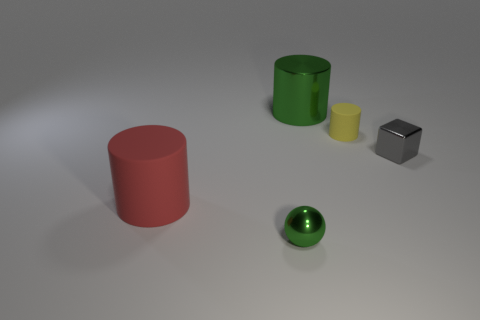There is a green metal thing in front of the big thing in front of the big green cylinder; what shape is it?
Give a very brief answer. Sphere. There is a shiny thing that is both on the left side of the small matte thing and behind the green metal sphere; what is its size?
Keep it short and to the point. Large. Are there any other red matte objects of the same shape as the tiny matte thing?
Provide a short and direct response. Yes. Are there any other things that are the same shape as the big red object?
Keep it short and to the point. Yes. What is the material of the cylinder to the left of the green metal object that is behind the tiny object in front of the tiny gray object?
Give a very brief answer. Rubber. Is there a green metallic sphere that has the same size as the metal cube?
Provide a short and direct response. Yes. The small metal object right of the green shiny object that is right of the small ball is what color?
Your answer should be compact. Gray. What number of brown spheres are there?
Give a very brief answer. 0. Does the metallic cylinder have the same color as the small cylinder?
Make the answer very short. No. Are there fewer matte objects that are on the right side of the tiny yellow cylinder than big red rubber cylinders that are right of the metallic sphere?
Offer a terse response. No. 